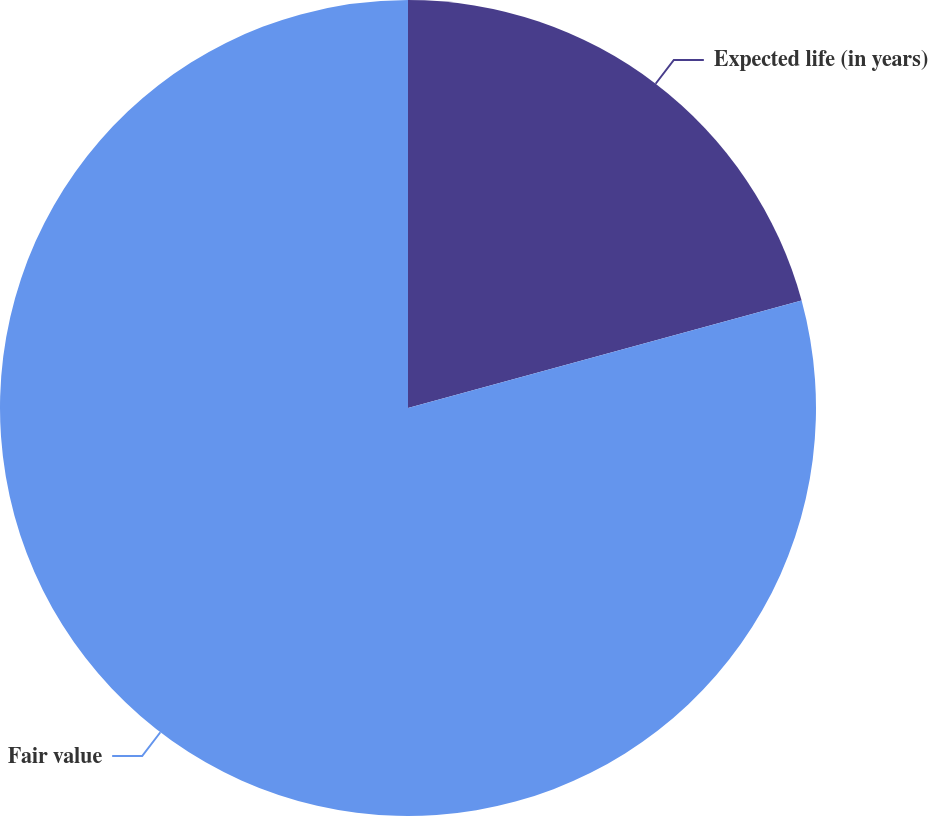Convert chart. <chart><loc_0><loc_0><loc_500><loc_500><pie_chart><fcel>Expected life (in years)<fcel>Fair value<nl><fcel>20.76%<fcel>79.24%<nl></chart> 